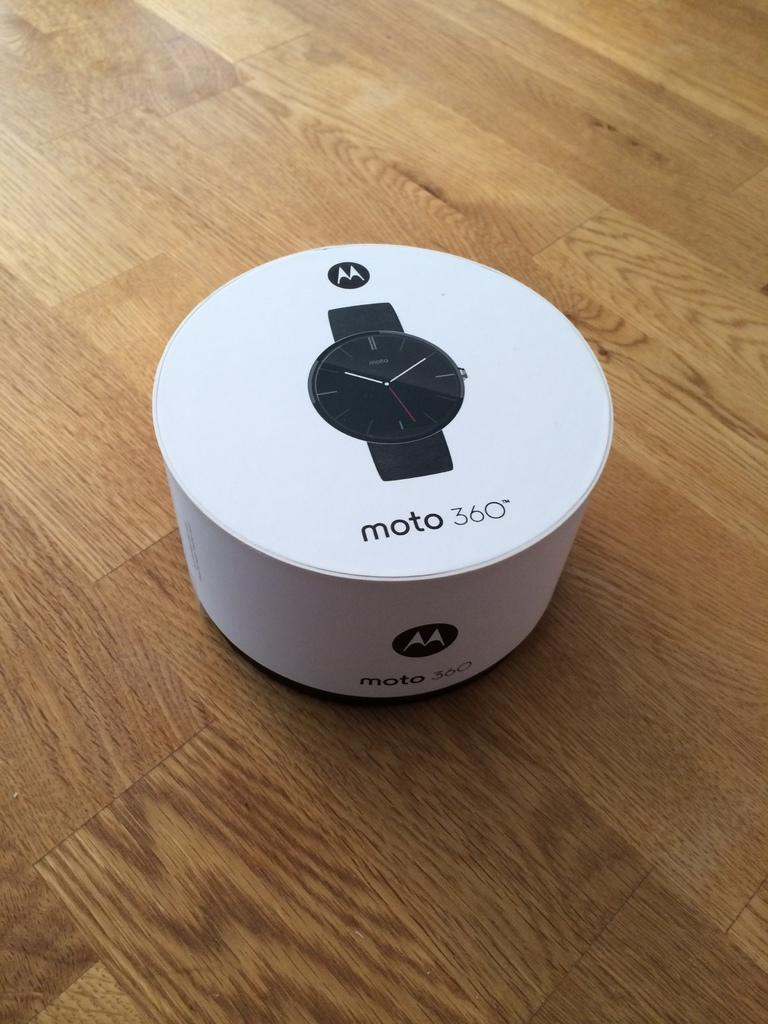<image>
Offer a succinct explanation of the picture presented. The blackMOTO watch from Motorola in a round white display unit 